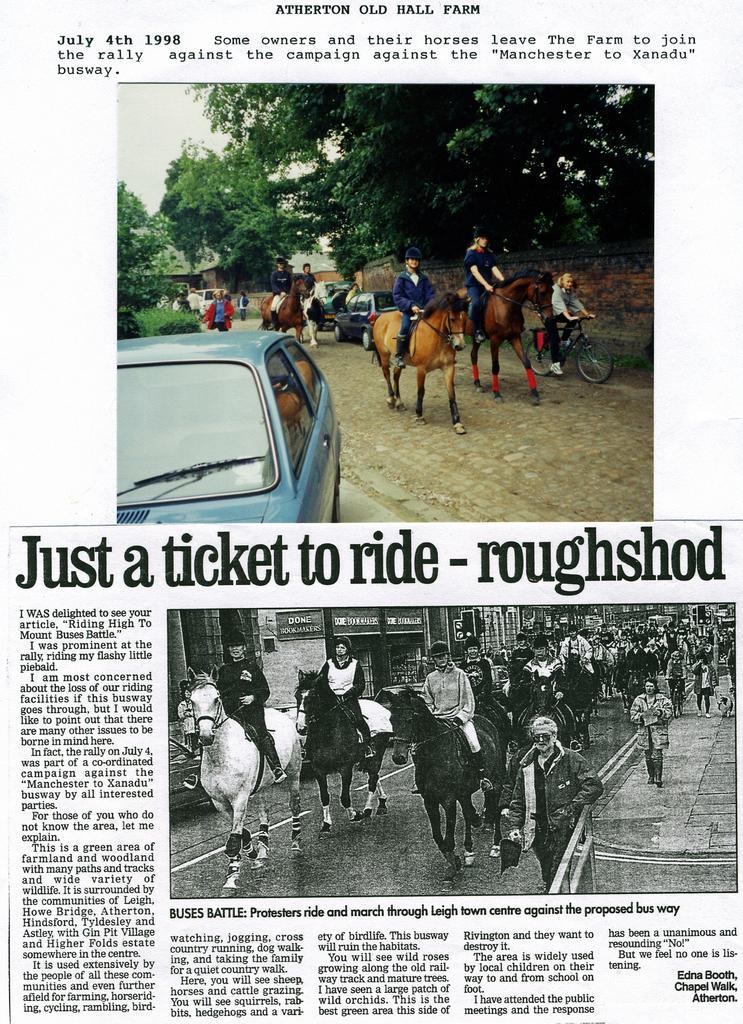How would you summarize this image in a sentence or two? in this image I see pictures, where I can see number of horse on which there are people sitting and I see few more people who are on the path and I see a car over here and I see something is written and I see number of trees. 